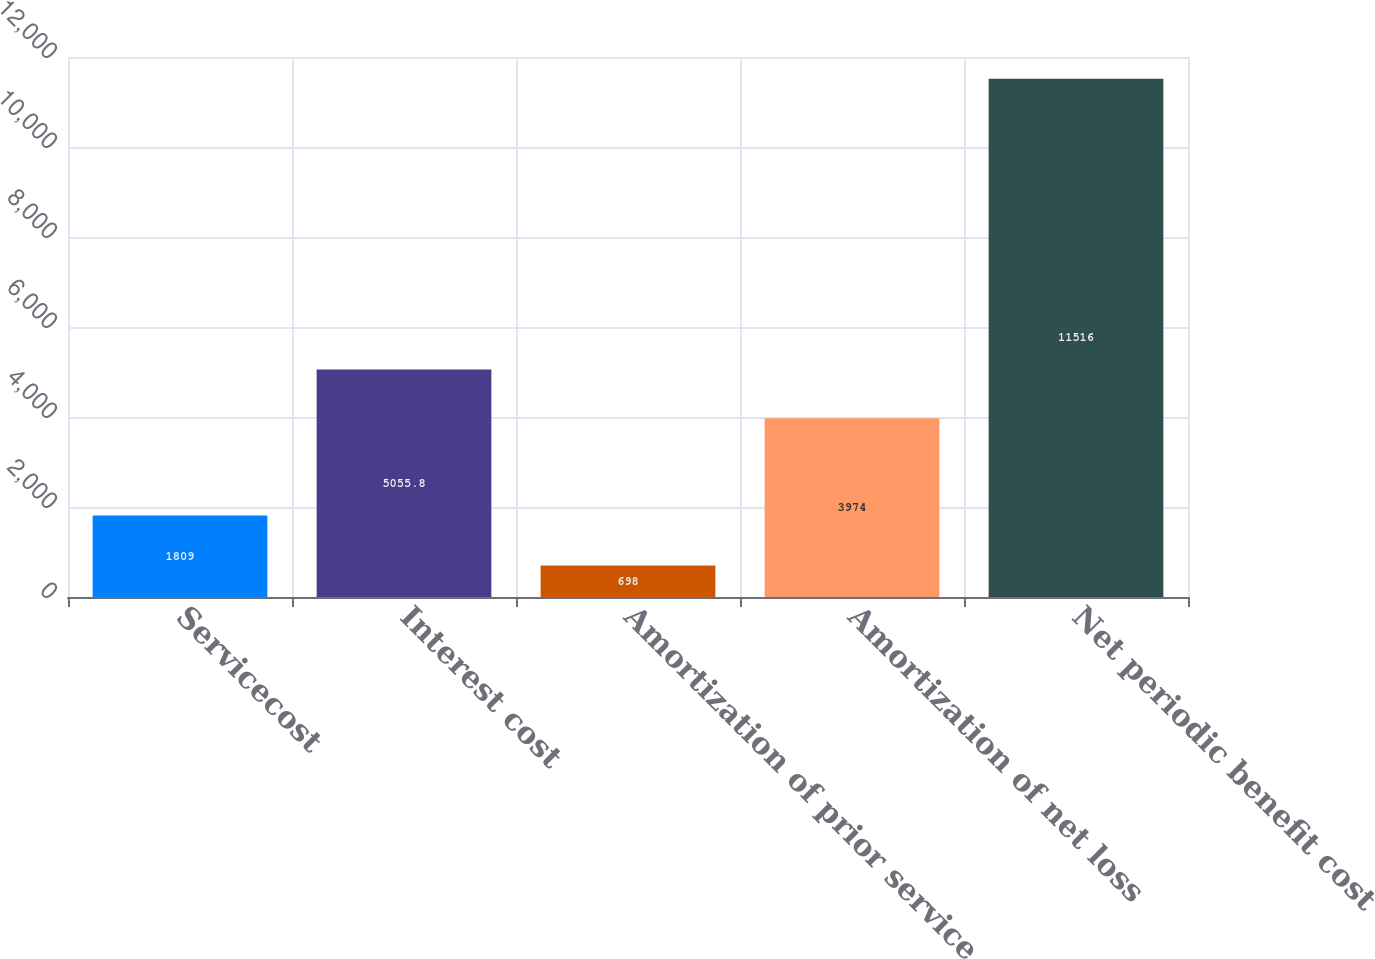<chart> <loc_0><loc_0><loc_500><loc_500><bar_chart><fcel>Servicecost<fcel>Interest cost<fcel>Amortization of prior service<fcel>Amortization of net loss<fcel>Net periodic benefit cost<nl><fcel>1809<fcel>5055.8<fcel>698<fcel>3974<fcel>11516<nl></chart> 